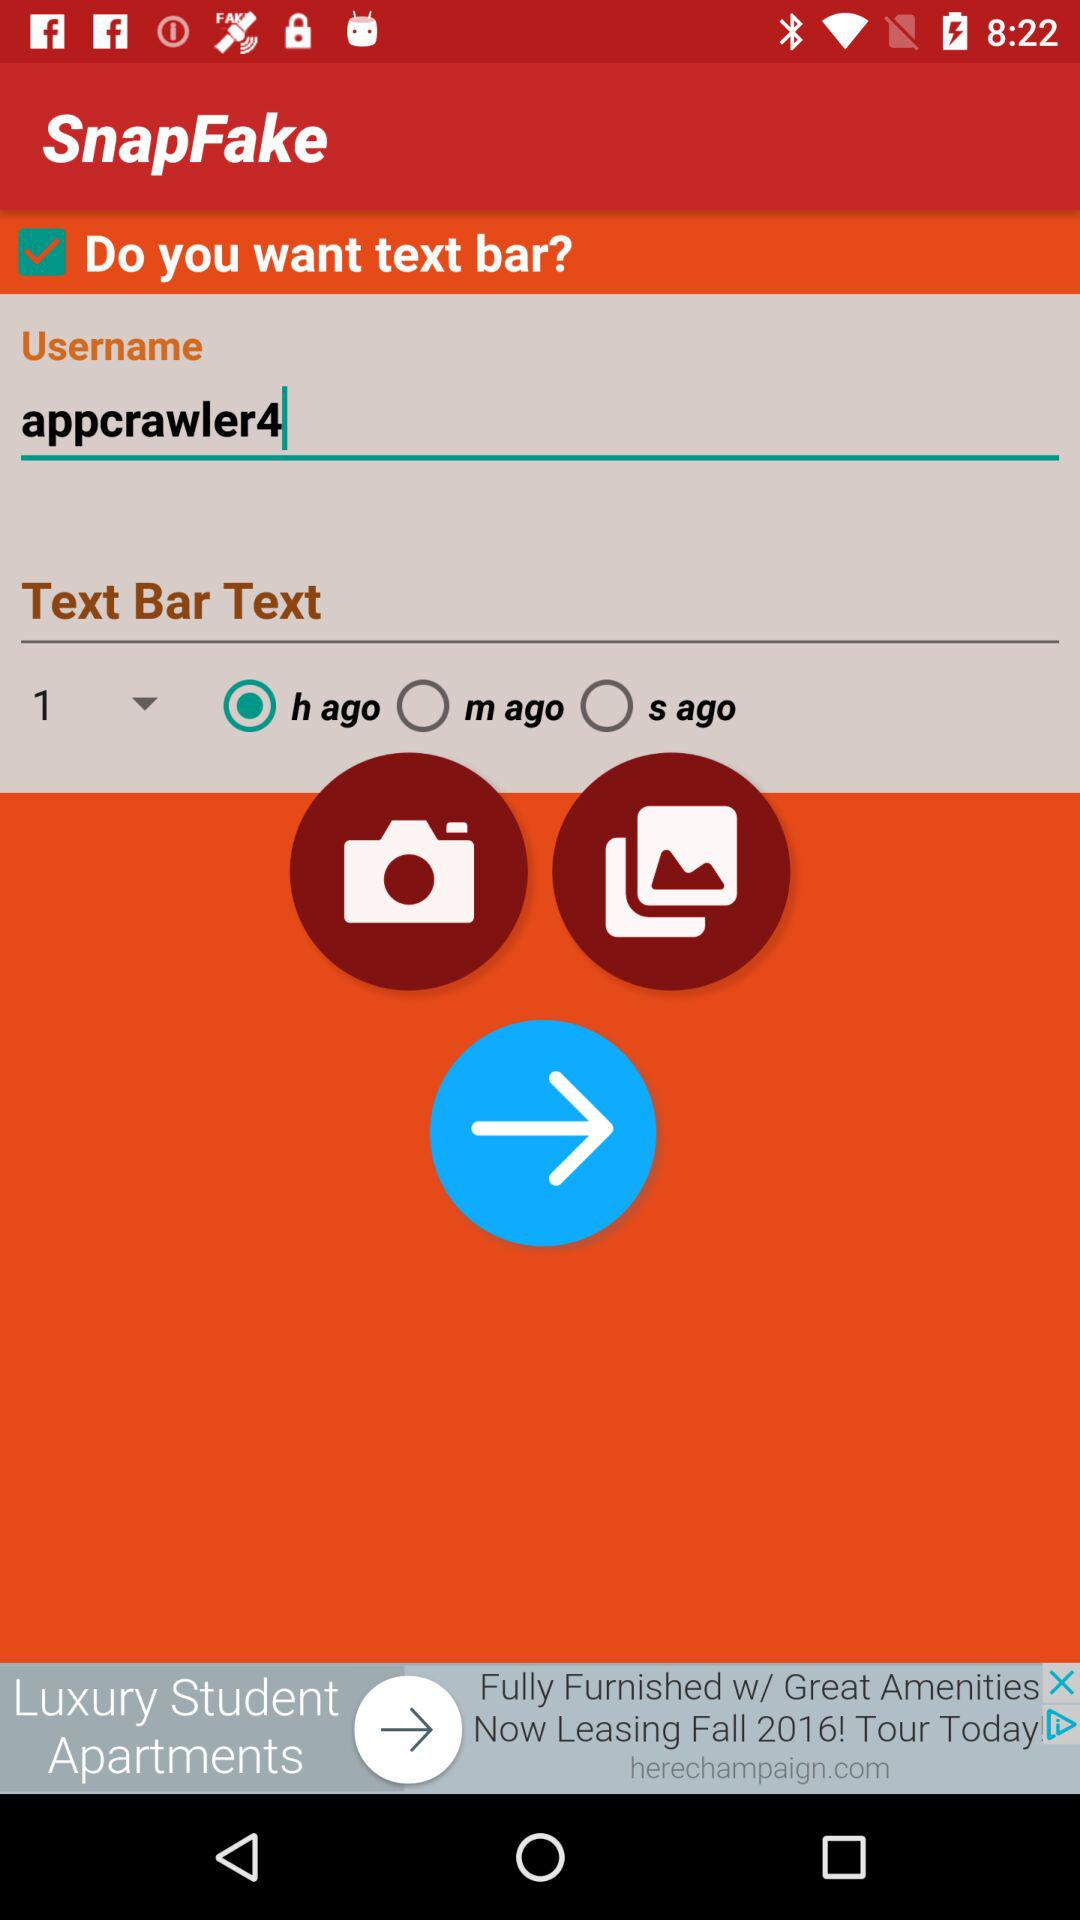What is the status of "Do you want text bar"? The status is "on". 